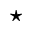<formula> <loc_0><loc_0><loc_500><loc_500>^ { * }</formula> 